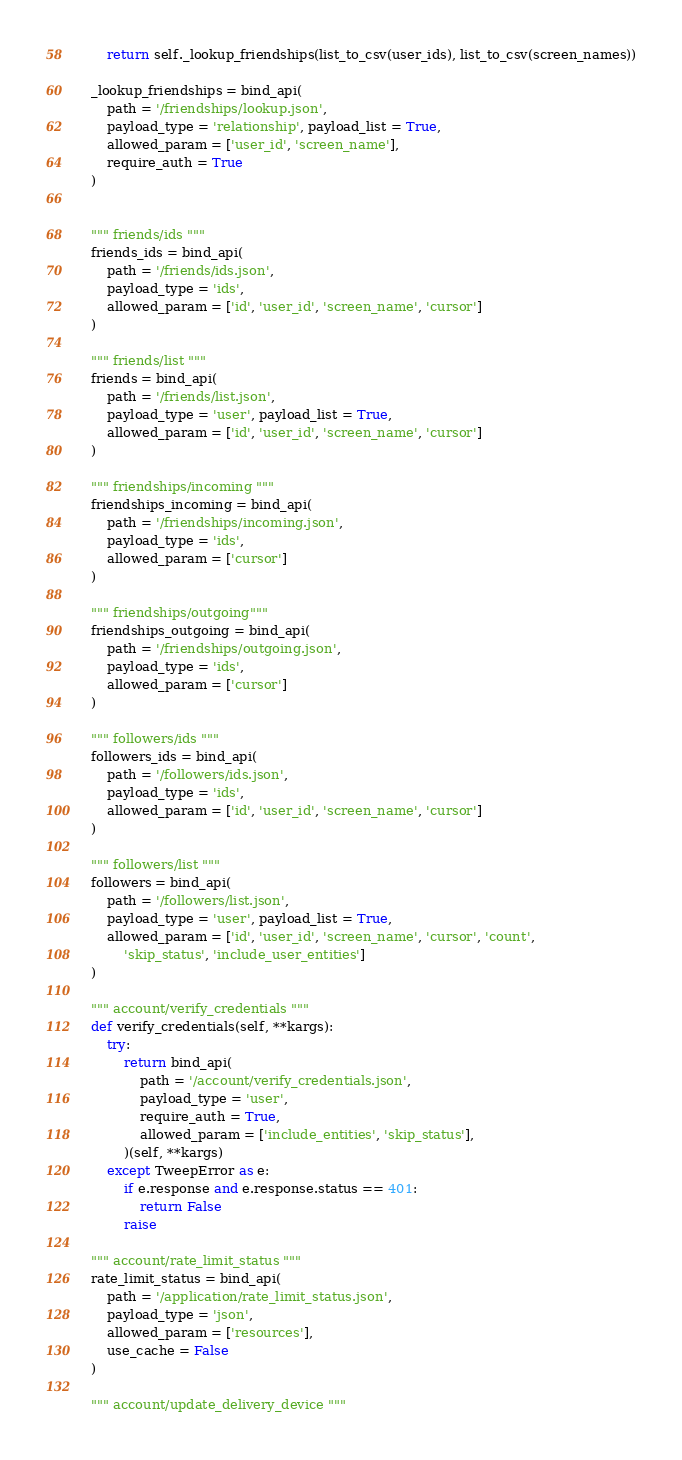Convert code to text. <code><loc_0><loc_0><loc_500><loc_500><_Python_>        return self._lookup_friendships(list_to_csv(user_ids), list_to_csv(screen_names))

    _lookup_friendships = bind_api(
        path = '/friendships/lookup.json',
        payload_type = 'relationship', payload_list = True,
        allowed_param = ['user_id', 'screen_name'],
        require_auth = True
    )


    """ friends/ids """
    friends_ids = bind_api(
        path = '/friends/ids.json',
        payload_type = 'ids',
        allowed_param = ['id', 'user_id', 'screen_name', 'cursor']
    )

    """ friends/list """
    friends = bind_api(
        path = '/friends/list.json',
        payload_type = 'user', payload_list = True,
        allowed_param = ['id', 'user_id', 'screen_name', 'cursor']
    )

    """ friendships/incoming """
    friendships_incoming = bind_api(
        path = '/friendships/incoming.json',
        payload_type = 'ids',
        allowed_param = ['cursor']
    )

    """ friendships/outgoing"""
    friendships_outgoing = bind_api(
        path = '/friendships/outgoing.json',
        payload_type = 'ids',
        allowed_param = ['cursor']
    )

    """ followers/ids """
    followers_ids = bind_api(
        path = '/followers/ids.json',
        payload_type = 'ids',
        allowed_param = ['id', 'user_id', 'screen_name', 'cursor']
    )

    """ followers/list """
    followers = bind_api(
        path = '/followers/list.json',
        payload_type = 'user', payload_list = True,
        allowed_param = ['id', 'user_id', 'screen_name', 'cursor', 'count',
            'skip_status', 'include_user_entities']
    )

    """ account/verify_credentials """
    def verify_credentials(self, **kargs):
        try:
            return bind_api(
                path = '/account/verify_credentials.json',
                payload_type = 'user',
                require_auth = True,
                allowed_param = ['include_entities', 'skip_status'],
            )(self, **kargs)
        except TweepError as e:
            if e.response and e.response.status == 401:
                return False
            raise

    """ account/rate_limit_status """
    rate_limit_status = bind_api(
        path = '/application/rate_limit_status.json',
        payload_type = 'json',
        allowed_param = ['resources'],
        use_cache = False
    )

    """ account/update_delivery_device """</code> 